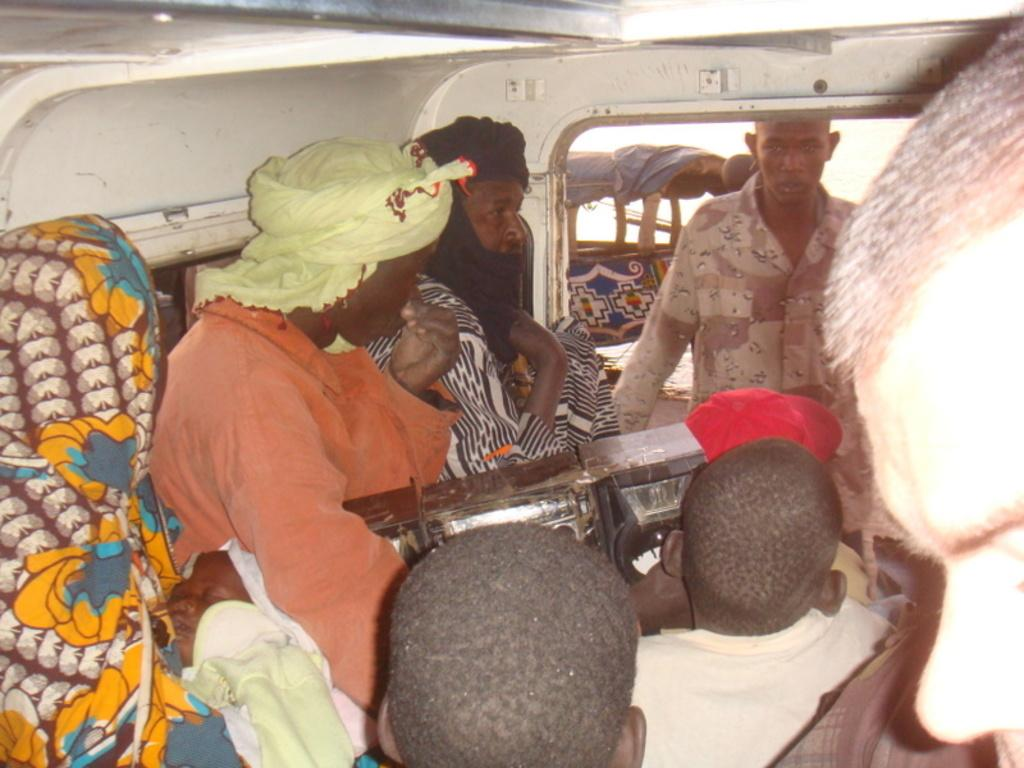What type of vehicle is in the image? The image contains a vehicle, but the specific type is not mentioned in the facts. What are the people in the image doing? There is a group of people sitting in the image, but their activity is not specified. How can you identify the person with the orange shirt in the image? The person with the orange shirt is distinguishable by the color of their shirt. What is the person with the orange shirt holding? The person with the orange shirt is holding an object, but the nature of the object is not described in the facts. What time is the baby actor performing in the image? There is no baby or actor present in the image, so it is not possible to determine the time of a performance. 